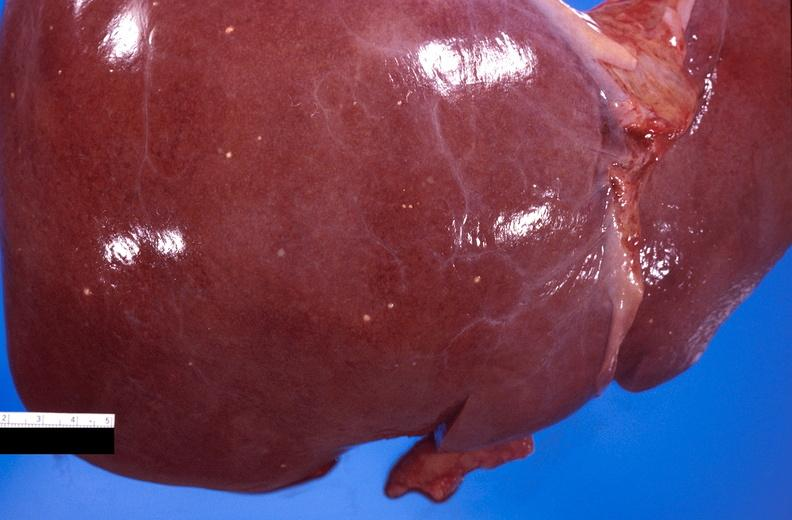s amputation stump infected present?
Answer the question using a single word or phrase. No 